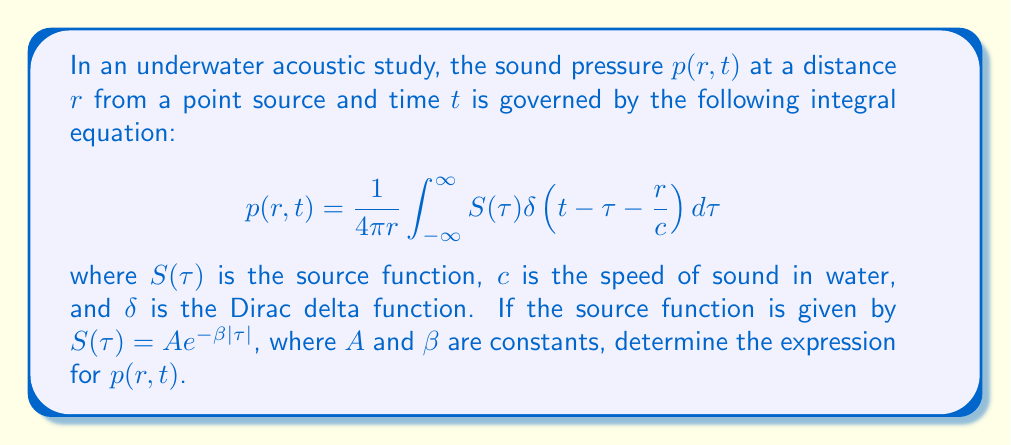Can you solve this math problem? Let's solve this step-by-step:

1) First, we substitute the given source function into the integral equation:

   $$p(r,t) = \frac{1}{4\pi r} \int_{-\infty}^{\infty} A e^{-\beta |\tau|} \delta(t - \tau - \frac{r}{c}) d\tau$$

2) The Dirac delta function has the sifting property, which states that:

   $$\int_{-\infty}^{\infty} f(x) \delta(x - a) dx = f(a)$$

3) Applying this property to our integral, we get:

   $$p(r,t) = \frac{1}{4\pi r} A e^{-\beta |t - \frac{r}{c}|}$$

4) This is because the delta function picks out the value of $\tau$ where its argument is zero:

   $$t - \tau - \frac{r}{c} = 0 \implies \tau = t - \frac{r}{c}$$

5) The absolute value in the exponent remains because we don't know if $(t - \frac{r}{c})$ is positive or negative.

6) We can simplify this further by noting that in most practical cases, $t > \frac{r}{c}$ (the observation time is greater than the time it takes for sound to travel the distance $r$). In this case:

   $$p(r,t) = \frac{A}{4\pi r} e^{-\beta (t - \frac{r}{c})}$$

This final expression gives the sound pressure as a function of distance and time for the given source function.
Answer: $$p(r,t) = \frac{A}{4\pi r} e^{-\beta |t - \frac{r}{c}|}$$ 